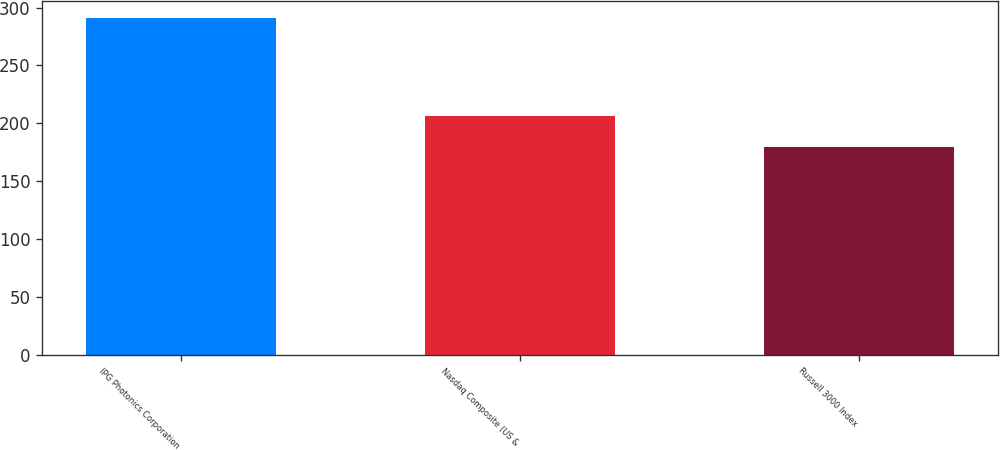Convert chart to OTSL. <chart><loc_0><loc_0><loc_500><loc_500><bar_chart><fcel>IPG Photonics Corporation<fcel>Nasdaq Composite (US &<fcel>Russell 3000 Index<nl><fcel>291.44<fcel>206.63<fcel>179.34<nl></chart> 